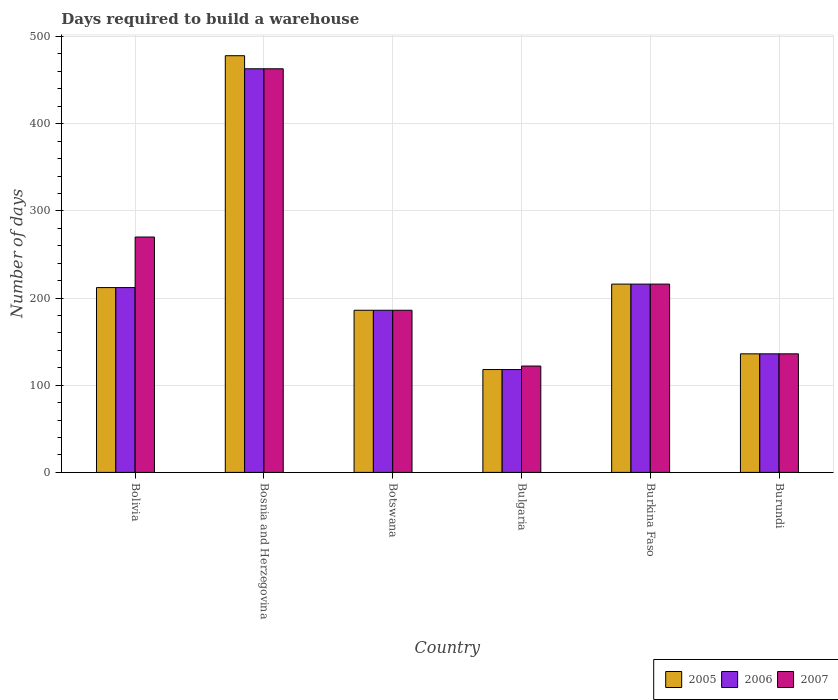How many different coloured bars are there?
Your answer should be very brief. 3. Are the number of bars per tick equal to the number of legend labels?
Offer a very short reply. Yes. Are the number of bars on each tick of the X-axis equal?
Keep it short and to the point. Yes. How many bars are there on the 2nd tick from the left?
Ensure brevity in your answer.  3. How many bars are there on the 5th tick from the right?
Make the answer very short. 3. What is the label of the 2nd group of bars from the left?
Your response must be concise. Bosnia and Herzegovina. What is the days required to build a warehouse in in 2005 in Bosnia and Herzegovina?
Your answer should be very brief. 478. Across all countries, what is the maximum days required to build a warehouse in in 2005?
Provide a short and direct response. 478. Across all countries, what is the minimum days required to build a warehouse in in 2005?
Your answer should be very brief. 118. In which country was the days required to build a warehouse in in 2006 maximum?
Make the answer very short. Bosnia and Herzegovina. What is the total days required to build a warehouse in in 2005 in the graph?
Provide a succinct answer. 1346. What is the difference between the days required to build a warehouse in in 2007 in Bosnia and Herzegovina and that in Burundi?
Offer a very short reply. 327. What is the average days required to build a warehouse in in 2006 per country?
Your response must be concise. 221.83. In how many countries, is the days required to build a warehouse in in 2007 greater than 340 days?
Ensure brevity in your answer.  1. What is the ratio of the days required to build a warehouse in in 2007 in Bosnia and Herzegovina to that in Burundi?
Your response must be concise. 3.4. What is the difference between the highest and the lowest days required to build a warehouse in in 2005?
Your answer should be very brief. 360. In how many countries, is the days required to build a warehouse in in 2005 greater than the average days required to build a warehouse in in 2005 taken over all countries?
Your answer should be compact. 1. Is the sum of the days required to build a warehouse in in 2007 in Bolivia and Burundi greater than the maximum days required to build a warehouse in in 2006 across all countries?
Your answer should be very brief. No. What does the 2nd bar from the left in Bolivia represents?
Make the answer very short. 2006. What does the 1st bar from the right in Bosnia and Herzegovina represents?
Provide a short and direct response. 2007. Is it the case that in every country, the sum of the days required to build a warehouse in in 2005 and days required to build a warehouse in in 2006 is greater than the days required to build a warehouse in in 2007?
Your answer should be compact. Yes. How many bars are there?
Offer a terse response. 18. Are all the bars in the graph horizontal?
Your answer should be very brief. No. What is the difference between two consecutive major ticks on the Y-axis?
Offer a very short reply. 100. Are the values on the major ticks of Y-axis written in scientific E-notation?
Ensure brevity in your answer.  No. How are the legend labels stacked?
Your answer should be very brief. Horizontal. What is the title of the graph?
Make the answer very short. Days required to build a warehouse. Does "1968" appear as one of the legend labels in the graph?
Provide a short and direct response. No. What is the label or title of the Y-axis?
Make the answer very short. Number of days. What is the Number of days in 2005 in Bolivia?
Give a very brief answer. 212. What is the Number of days of 2006 in Bolivia?
Your response must be concise. 212. What is the Number of days of 2007 in Bolivia?
Provide a short and direct response. 270. What is the Number of days in 2005 in Bosnia and Herzegovina?
Keep it short and to the point. 478. What is the Number of days in 2006 in Bosnia and Herzegovina?
Keep it short and to the point. 463. What is the Number of days in 2007 in Bosnia and Herzegovina?
Provide a succinct answer. 463. What is the Number of days in 2005 in Botswana?
Your answer should be very brief. 186. What is the Number of days of 2006 in Botswana?
Offer a very short reply. 186. What is the Number of days of 2007 in Botswana?
Provide a short and direct response. 186. What is the Number of days in 2005 in Bulgaria?
Make the answer very short. 118. What is the Number of days in 2006 in Bulgaria?
Provide a succinct answer. 118. What is the Number of days in 2007 in Bulgaria?
Provide a succinct answer. 122. What is the Number of days of 2005 in Burkina Faso?
Your answer should be very brief. 216. What is the Number of days of 2006 in Burkina Faso?
Offer a very short reply. 216. What is the Number of days in 2007 in Burkina Faso?
Provide a short and direct response. 216. What is the Number of days in 2005 in Burundi?
Offer a terse response. 136. What is the Number of days in 2006 in Burundi?
Your answer should be very brief. 136. What is the Number of days of 2007 in Burundi?
Your answer should be compact. 136. Across all countries, what is the maximum Number of days in 2005?
Provide a short and direct response. 478. Across all countries, what is the maximum Number of days of 2006?
Offer a terse response. 463. Across all countries, what is the maximum Number of days in 2007?
Ensure brevity in your answer.  463. Across all countries, what is the minimum Number of days of 2005?
Ensure brevity in your answer.  118. Across all countries, what is the minimum Number of days in 2006?
Provide a succinct answer. 118. Across all countries, what is the minimum Number of days in 2007?
Offer a terse response. 122. What is the total Number of days of 2005 in the graph?
Keep it short and to the point. 1346. What is the total Number of days of 2006 in the graph?
Your answer should be very brief. 1331. What is the total Number of days in 2007 in the graph?
Offer a terse response. 1393. What is the difference between the Number of days in 2005 in Bolivia and that in Bosnia and Herzegovina?
Provide a short and direct response. -266. What is the difference between the Number of days of 2006 in Bolivia and that in Bosnia and Herzegovina?
Offer a terse response. -251. What is the difference between the Number of days of 2007 in Bolivia and that in Bosnia and Herzegovina?
Offer a very short reply. -193. What is the difference between the Number of days in 2005 in Bolivia and that in Botswana?
Provide a succinct answer. 26. What is the difference between the Number of days in 2006 in Bolivia and that in Botswana?
Ensure brevity in your answer.  26. What is the difference between the Number of days of 2005 in Bolivia and that in Bulgaria?
Provide a succinct answer. 94. What is the difference between the Number of days of 2006 in Bolivia and that in Bulgaria?
Make the answer very short. 94. What is the difference between the Number of days in 2007 in Bolivia and that in Bulgaria?
Ensure brevity in your answer.  148. What is the difference between the Number of days in 2005 in Bolivia and that in Burkina Faso?
Keep it short and to the point. -4. What is the difference between the Number of days in 2007 in Bolivia and that in Burkina Faso?
Ensure brevity in your answer.  54. What is the difference between the Number of days of 2007 in Bolivia and that in Burundi?
Keep it short and to the point. 134. What is the difference between the Number of days in 2005 in Bosnia and Herzegovina and that in Botswana?
Your response must be concise. 292. What is the difference between the Number of days in 2006 in Bosnia and Herzegovina and that in Botswana?
Ensure brevity in your answer.  277. What is the difference between the Number of days of 2007 in Bosnia and Herzegovina and that in Botswana?
Make the answer very short. 277. What is the difference between the Number of days in 2005 in Bosnia and Herzegovina and that in Bulgaria?
Your answer should be very brief. 360. What is the difference between the Number of days in 2006 in Bosnia and Herzegovina and that in Bulgaria?
Make the answer very short. 345. What is the difference between the Number of days of 2007 in Bosnia and Herzegovina and that in Bulgaria?
Keep it short and to the point. 341. What is the difference between the Number of days of 2005 in Bosnia and Herzegovina and that in Burkina Faso?
Make the answer very short. 262. What is the difference between the Number of days in 2006 in Bosnia and Herzegovina and that in Burkina Faso?
Ensure brevity in your answer.  247. What is the difference between the Number of days of 2007 in Bosnia and Herzegovina and that in Burkina Faso?
Your answer should be compact. 247. What is the difference between the Number of days of 2005 in Bosnia and Herzegovina and that in Burundi?
Keep it short and to the point. 342. What is the difference between the Number of days of 2006 in Bosnia and Herzegovina and that in Burundi?
Your answer should be very brief. 327. What is the difference between the Number of days of 2007 in Bosnia and Herzegovina and that in Burundi?
Ensure brevity in your answer.  327. What is the difference between the Number of days in 2006 in Botswana and that in Bulgaria?
Provide a short and direct response. 68. What is the difference between the Number of days of 2006 in Botswana and that in Burkina Faso?
Your answer should be very brief. -30. What is the difference between the Number of days of 2005 in Botswana and that in Burundi?
Provide a succinct answer. 50. What is the difference between the Number of days in 2006 in Botswana and that in Burundi?
Your answer should be very brief. 50. What is the difference between the Number of days of 2007 in Botswana and that in Burundi?
Offer a very short reply. 50. What is the difference between the Number of days of 2005 in Bulgaria and that in Burkina Faso?
Your answer should be compact. -98. What is the difference between the Number of days in 2006 in Bulgaria and that in Burkina Faso?
Offer a terse response. -98. What is the difference between the Number of days of 2007 in Bulgaria and that in Burkina Faso?
Make the answer very short. -94. What is the difference between the Number of days in 2006 in Bulgaria and that in Burundi?
Keep it short and to the point. -18. What is the difference between the Number of days of 2007 in Bulgaria and that in Burundi?
Offer a very short reply. -14. What is the difference between the Number of days in 2006 in Burkina Faso and that in Burundi?
Your answer should be compact. 80. What is the difference between the Number of days of 2005 in Bolivia and the Number of days of 2006 in Bosnia and Herzegovina?
Make the answer very short. -251. What is the difference between the Number of days of 2005 in Bolivia and the Number of days of 2007 in Bosnia and Herzegovina?
Keep it short and to the point. -251. What is the difference between the Number of days in 2006 in Bolivia and the Number of days in 2007 in Bosnia and Herzegovina?
Provide a succinct answer. -251. What is the difference between the Number of days in 2005 in Bolivia and the Number of days in 2007 in Botswana?
Provide a succinct answer. 26. What is the difference between the Number of days of 2006 in Bolivia and the Number of days of 2007 in Botswana?
Give a very brief answer. 26. What is the difference between the Number of days of 2005 in Bolivia and the Number of days of 2006 in Bulgaria?
Your response must be concise. 94. What is the difference between the Number of days in 2005 in Bolivia and the Number of days in 2007 in Bulgaria?
Provide a short and direct response. 90. What is the difference between the Number of days in 2006 in Bolivia and the Number of days in 2007 in Burkina Faso?
Your answer should be compact. -4. What is the difference between the Number of days in 2005 in Bolivia and the Number of days in 2006 in Burundi?
Offer a very short reply. 76. What is the difference between the Number of days in 2006 in Bolivia and the Number of days in 2007 in Burundi?
Make the answer very short. 76. What is the difference between the Number of days of 2005 in Bosnia and Herzegovina and the Number of days of 2006 in Botswana?
Your answer should be very brief. 292. What is the difference between the Number of days in 2005 in Bosnia and Herzegovina and the Number of days in 2007 in Botswana?
Provide a short and direct response. 292. What is the difference between the Number of days of 2006 in Bosnia and Herzegovina and the Number of days of 2007 in Botswana?
Provide a short and direct response. 277. What is the difference between the Number of days of 2005 in Bosnia and Herzegovina and the Number of days of 2006 in Bulgaria?
Your response must be concise. 360. What is the difference between the Number of days in 2005 in Bosnia and Herzegovina and the Number of days in 2007 in Bulgaria?
Your answer should be very brief. 356. What is the difference between the Number of days of 2006 in Bosnia and Herzegovina and the Number of days of 2007 in Bulgaria?
Provide a short and direct response. 341. What is the difference between the Number of days in 2005 in Bosnia and Herzegovina and the Number of days in 2006 in Burkina Faso?
Your response must be concise. 262. What is the difference between the Number of days of 2005 in Bosnia and Herzegovina and the Number of days of 2007 in Burkina Faso?
Provide a short and direct response. 262. What is the difference between the Number of days of 2006 in Bosnia and Herzegovina and the Number of days of 2007 in Burkina Faso?
Make the answer very short. 247. What is the difference between the Number of days in 2005 in Bosnia and Herzegovina and the Number of days in 2006 in Burundi?
Your response must be concise. 342. What is the difference between the Number of days in 2005 in Bosnia and Herzegovina and the Number of days in 2007 in Burundi?
Keep it short and to the point. 342. What is the difference between the Number of days of 2006 in Bosnia and Herzegovina and the Number of days of 2007 in Burundi?
Provide a succinct answer. 327. What is the difference between the Number of days in 2005 in Botswana and the Number of days in 2006 in Bulgaria?
Provide a short and direct response. 68. What is the difference between the Number of days in 2005 in Botswana and the Number of days in 2007 in Bulgaria?
Your answer should be very brief. 64. What is the difference between the Number of days in 2006 in Botswana and the Number of days in 2007 in Bulgaria?
Your answer should be compact. 64. What is the difference between the Number of days in 2006 in Botswana and the Number of days in 2007 in Burkina Faso?
Ensure brevity in your answer.  -30. What is the difference between the Number of days in 2005 in Botswana and the Number of days in 2006 in Burundi?
Provide a short and direct response. 50. What is the difference between the Number of days of 2006 in Botswana and the Number of days of 2007 in Burundi?
Ensure brevity in your answer.  50. What is the difference between the Number of days in 2005 in Bulgaria and the Number of days in 2006 in Burkina Faso?
Make the answer very short. -98. What is the difference between the Number of days in 2005 in Bulgaria and the Number of days in 2007 in Burkina Faso?
Your response must be concise. -98. What is the difference between the Number of days of 2006 in Bulgaria and the Number of days of 2007 in Burkina Faso?
Your answer should be very brief. -98. What is the difference between the Number of days of 2005 in Bulgaria and the Number of days of 2007 in Burundi?
Your response must be concise. -18. What is the difference between the Number of days of 2006 in Bulgaria and the Number of days of 2007 in Burundi?
Offer a terse response. -18. What is the difference between the Number of days in 2005 in Burkina Faso and the Number of days in 2006 in Burundi?
Provide a succinct answer. 80. What is the average Number of days in 2005 per country?
Your answer should be compact. 224.33. What is the average Number of days in 2006 per country?
Keep it short and to the point. 221.83. What is the average Number of days of 2007 per country?
Your answer should be very brief. 232.17. What is the difference between the Number of days in 2005 and Number of days in 2006 in Bolivia?
Make the answer very short. 0. What is the difference between the Number of days in 2005 and Number of days in 2007 in Bolivia?
Ensure brevity in your answer.  -58. What is the difference between the Number of days of 2006 and Number of days of 2007 in Bolivia?
Give a very brief answer. -58. What is the difference between the Number of days of 2005 and Number of days of 2007 in Botswana?
Give a very brief answer. 0. What is the difference between the Number of days in 2006 and Number of days in 2007 in Botswana?
Make the answer very short. 0. What is the difference between the Number of days in 2005 and Number of days in 2007 in Bulgaria?
Offer a terse response. -4. What is the difference between the Number of days of 2005 and Number of days of 2006 in Burkina Faso?
Provide a succinct answer. 0. What is the difference between the Number of days of 2005 and Number of days of 2006 in Burundi?
Your response must be concise. 0. What is the difference between the Number of days in 2005 and Number of days in 2007 in Burundi?
Offer a terse response. 0. What is the difference between the Number of days in 2006 and Number of days in 2007 in Burundi?
Give a very brief answer. 0. What is the ratio of the Number of days in 2005 in Bolivia to that in Bosnia and Herzegovina?
Keep it short and to the point. 0.44. What is the ratio of the Number of days of 2006 in Bolivia to that in Bosnia and Herzegovina?
Your response must be concise. 0.46. What is the ratio of the Number of days of 2007 in Bolivia to that in Bosnia and Herzegovina?
Provide a succinct answer. 0.58. What is the ratio of the Number of days of 2005 in Bolivia to that in Botswana?
Provide a short and direct response. 1.14. What is the ratio of the Number of days in 2006 in Bolivia to that in Botswana?
Keep it short and to the point. 1.14. What is the ratio of the Number of days of 2007 in Bolivia to that in Botswana?
Provide a short and direct response. 1.45. What is the ratio of the Number of days of 2005 in Bolivia to that in Bulgaria?
Keep it short and to the point. 1.8. What is the ratio of the Number of days in 2006 in Bolivia to that in Bulgaria?
Offer a very short reply. 1.8. What is the ratio of the Number of days of 2007 in Bolivia to that in Bulgaria?
Your answer should be very brief. 2.21. What is the ratio of the Number of days in 2005 in Bolivia to that in Burkina Faso?
Provide a short and direct response. 0.98. What is the ratio of the Number of days in 2006 in Bolivia to that in Burkina Faso?
Provide a short and direct response. 0.98. What is the ratio of the Number of days in 2007 in Bolivia to that in Burkina Faso?
Make the answer very short. 1.25. What is the ratio of the Number of days in 2005 in Bolivia to that in Burundi?
Keep it short and to the point. 1.56. What is the ratio of the Number of days of 2006 in Bolivia to that in Burundi?
Give a very brief answer. 1.56. What is the ratio of the Number of days in 2007 in Bolivia to that in Burundi?
Offer a terse response. 1.99. What is the ratio of the Number of days in 2005 in Bosnia and Herzegovina to that in Botswana?
Keep it short and to the point. 2.57. What is the ratio of the Number of days in 2006 in Bosnia and Herzegovina to that in Botswana?
Make the answer very short. 2.49. What is the ratio of the Number of days of 2007 in Bosnia and Herzegovina to that in Botswana?
Your answer should be very brief. 2.49. What is the ratio of the Number of days of 2005 in Bosnia and Herzegovina to that in Bulgaria?
Ensure brevity in your answer.  4.05. What is the ratio of the Number of days in 2006 in Bosnia and Herzegovina to that in Bulgaria?
Ensure brevity in your answer.  3.92. What is the ratio of the Number of days of 2007 in Bosnia and Herzegovina to that in Bulgaria?
Offer a terse response. 3.8. What is the ratio of the Number of days of 2005 in Bosnia and Herzegovina to that in Burkina Faso?
Keep it short and to the point. 2.21. What is the ratio of the Number of days of 2006 in Bosnia and Herzegovina to that in Burkina Faso?
Offer a very short reply. 2.14. What is the ratio of the Number of days in 2007 in Bosnia and Herzegovina to that in Burkina Faso?
Keep it short and to the point. 2.14. What is the ratio of the Number of days in 2005 in Bosnia and Herzegovina to that in Burundi?
Your answer should be very brief. 3.51. What is the ratio of the Number of days in 2006 in Bosnia and Herzegovina to that in Burundi?
Your response must be concise. 3.4. What is the ratio of the Number of days in 2007 in Bosnia and Herzegovina to that in Burundi?
Give a very brief answer. 3.4. What is the ratio of the Number of days in 2005 in Botswana to that in Bulgaria?
Your answer should be very brief. 1.58. What is the ratio of the Number of days in 2006 in Botswana to that in Bulgaria?
Your answer should be compact. 1.58. What is the ratio of the Number of days of 2007 in Botswana to that in Bulgaria?
Your response must be concise. 1.52. What is the ratio of the Number of days in 2005 in Botswana to that in Burkina Faso?
Give a very brief answer. 0.86. What is the ratio of the Number of days of 2006 in Botswana to that in Burkina Faso?
Your response must be concise. 0.86. What is the ratio of the Number of days in 2007 in Botswana to that in Burkina Faso?
Your answer should be very brief. 0.86. What is the ratio of the Number of days of 2005 in Botswana to that in Burundi?
Give a very brief answer. 1.37. What is the ratio of the Number of days in 2006 in Botswana to that in Burundi?
Offer a terse response. 1.37. What is the ratio of the Number of days in 2007 in Botswana to that in Burundi?
Give a very brief answer. 1.37. What is the ratio of the Number of days of 2005 in Bulgaria to that in Burkina Faso?
Offer a terse response. 0.55. What is the ratio of the Number of days of 2006 in Bulgaria to that in Burkina Faso?
Offer a very short reply. 0.55. What is the ratio of the Number of days of 2007 in Bulgaria to that in Burkina Faso?
Offer a terse response. 0.56. What is the ratio of the Number of days in 2005 in Bulgaria to that in Burundi?
Make the answer very short. 0.87. What is the ratio of the Number of days in 2006 in Bulgaria to that in Burundi?
Keep it short and to the point. 0.87. What is the ratio of the Number of days in 2007 in Bulgaria to that in Burundi?
Provide a succinct answer. 0.9. What is the ratio of the Number of days of 2005 in Burkina Faso to that in Burundi?
Your answer should be very brief. 1.59. What is the ratio of the Number of days in 2006 in Burkina Faso to that in Burundi?
Keep it short and to the point. 1.59. What is the ratio of the Number of days in 2007 in Burkina Faso to that in Burundi?
Offer a terse response. 1.59. What is the difference between the highest and the second highest Number of days of 2005?
Offer a terse response. 262. What is the difference between the highest and the second highest Number of days of 2006?
Provide a succinct answer. 247. What is the difference between the highest and the second highest Number of days in 2007?
Keep it short and to the point. 193. What is the difference between the highest and the lowest Number of days in 2005?
Your answer should be very brief. 360. What is the difference between the highest and the lowest Number of days of 2006?
Make the answer very short. 345. What is the difference between the highest and the lowest Number of days in 2007?
Your answer should be compact. 341. 